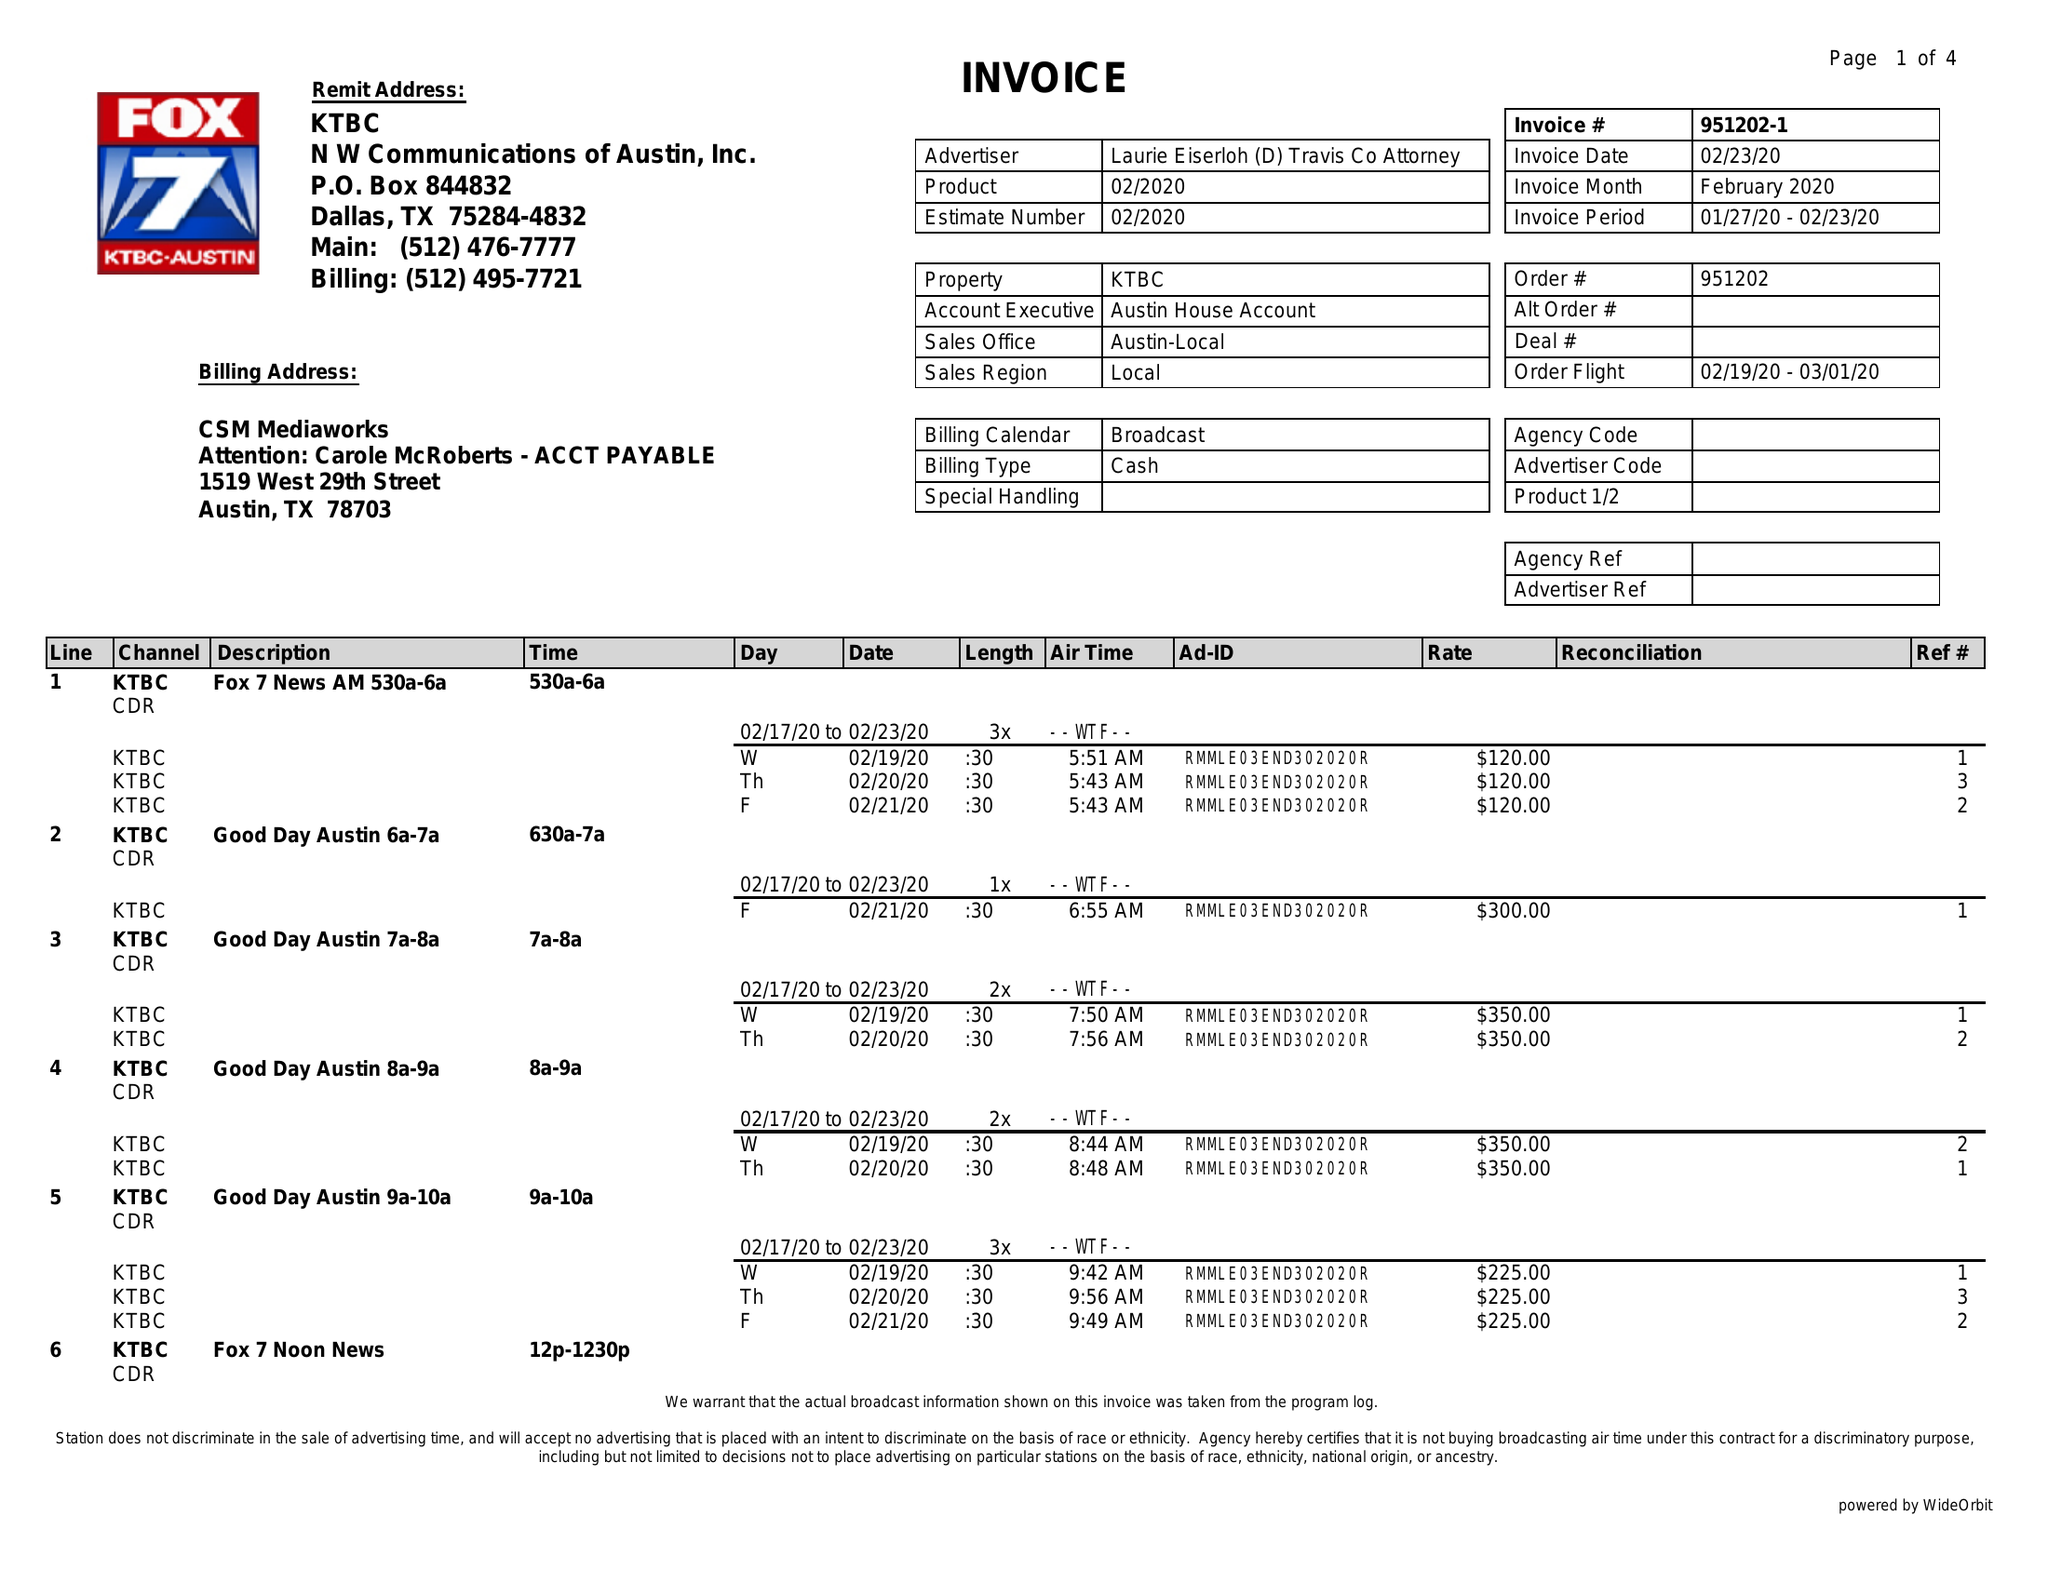What is the value for the advertiser?
Answer the question using a single word or phrase. LAURIE EISERLOH (D) TRAVIS CO ATTORNEY 